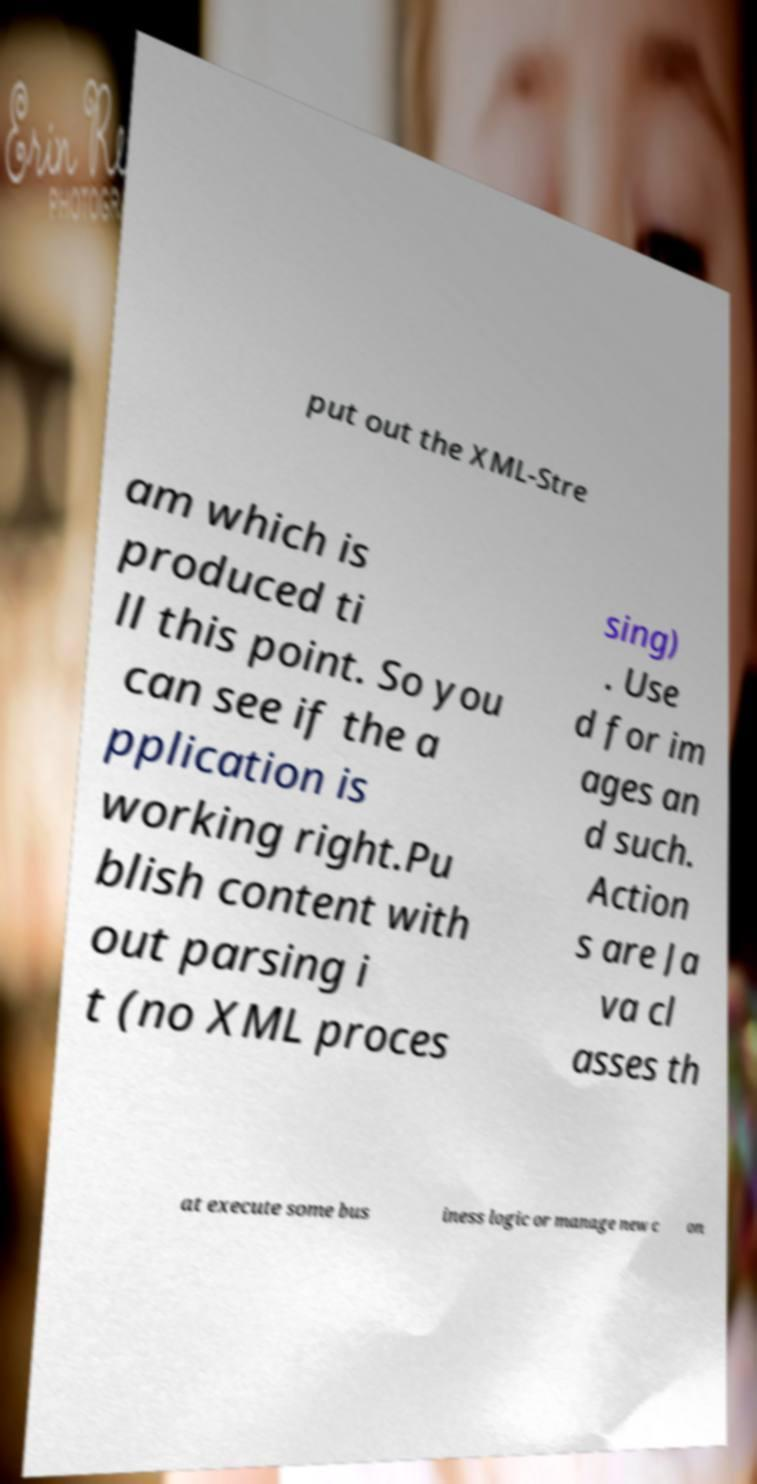There's text embedded in this image that I need extracted. Can you transcribe it verbatim? put out the XML-Stre am which is produced ti ll this point. So you can see if the a pplication is working right.Pu blish content with out parsing i t (no XML proces sing) . Use d for im ages an d such. Action s are Ja va cl asses th at execute some bus iness logic or manage new c on 